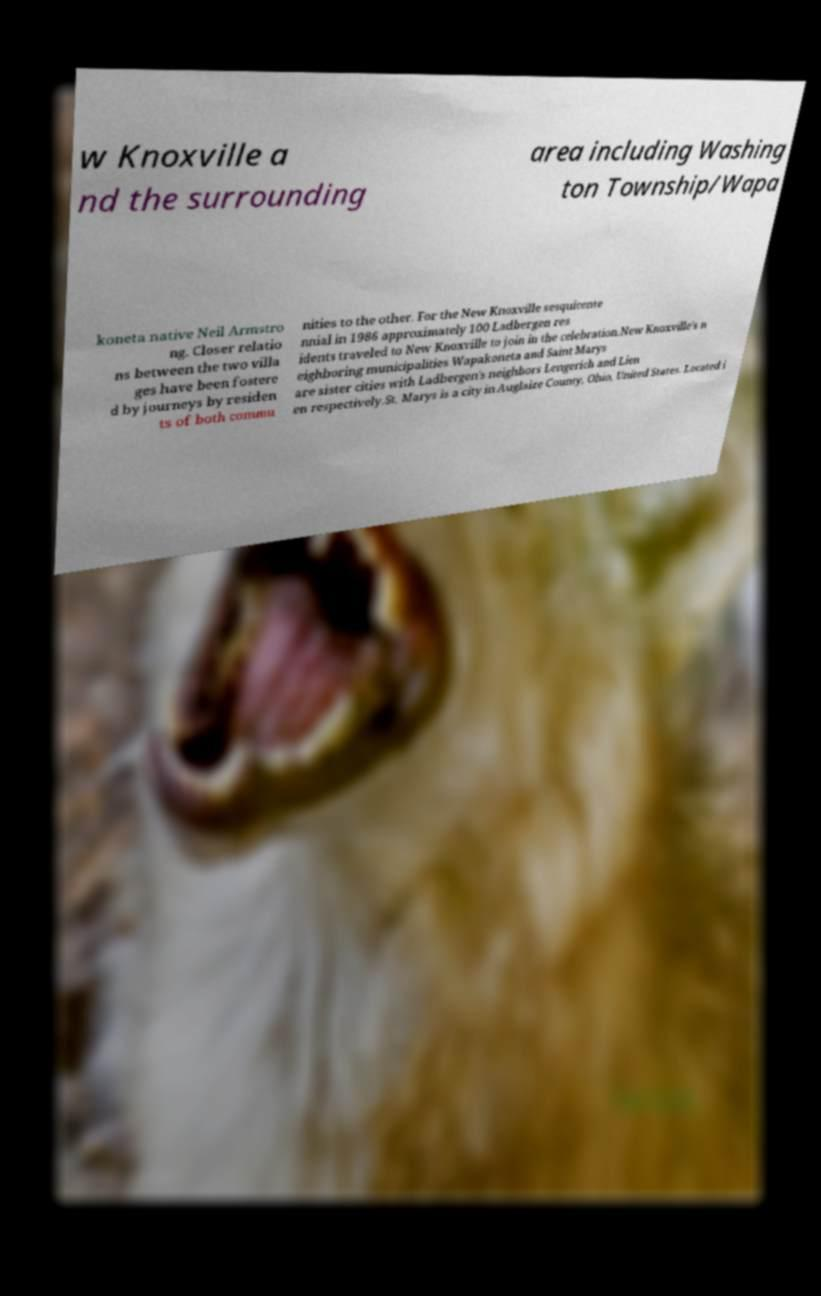Can you accurately transcribe the text from the provided image for me? w Knoxville a nd the surrounding area including Washing ton Township/Wapa koneta native Neil Armstro ng. Closer relatio ns between the two villa ges have been fostere d by journeys by residen ts of both commu nities to the other. For the New Knoxville sesquicente nnial in 1986 approximately 100 Ladbergen res idents traveled to New Knoxville to join in the celebration.New Knoxville's n eighboring municipalities Wapakoneta and Saint Marys are sister cities with Ladbergen's neighbors Lengerich and Lien en respectively.St. Marys is a city in Auglaize County, Ohio, United States. Located i 